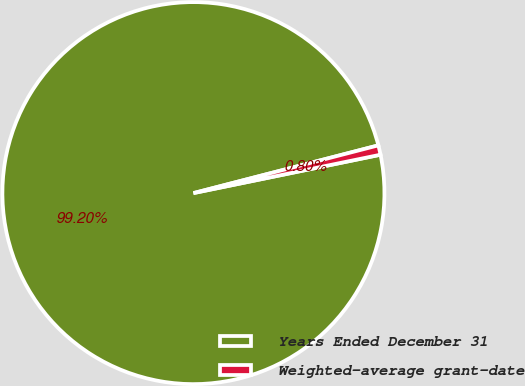Convert chart to OTSL. <chart><loc_0><loc_0><loc_500><loc_500><pie_chart><fcel>Years Ended December 31<fcel>Weighted-average grant-date<nl><fcel>99.2%<fcel>0.8%<nl></chart> 